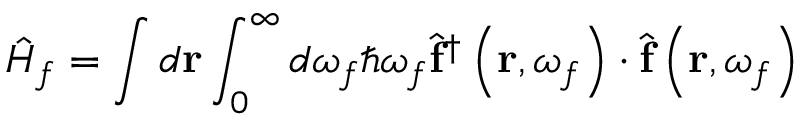<formula> <loc_0><loc_0><loc_500><loc_500>\hat { H } _ { f } = \int d r \int _ { 0 } ^ { \infty } d \omega _ { f } \hbar { \omega } _ { f } \hat { f } ^ { \dagger } \left ( r , \omega _ { f } \right ) \cdot \hat { f } \left ( r , \omega _ { f } \right )</formula> 